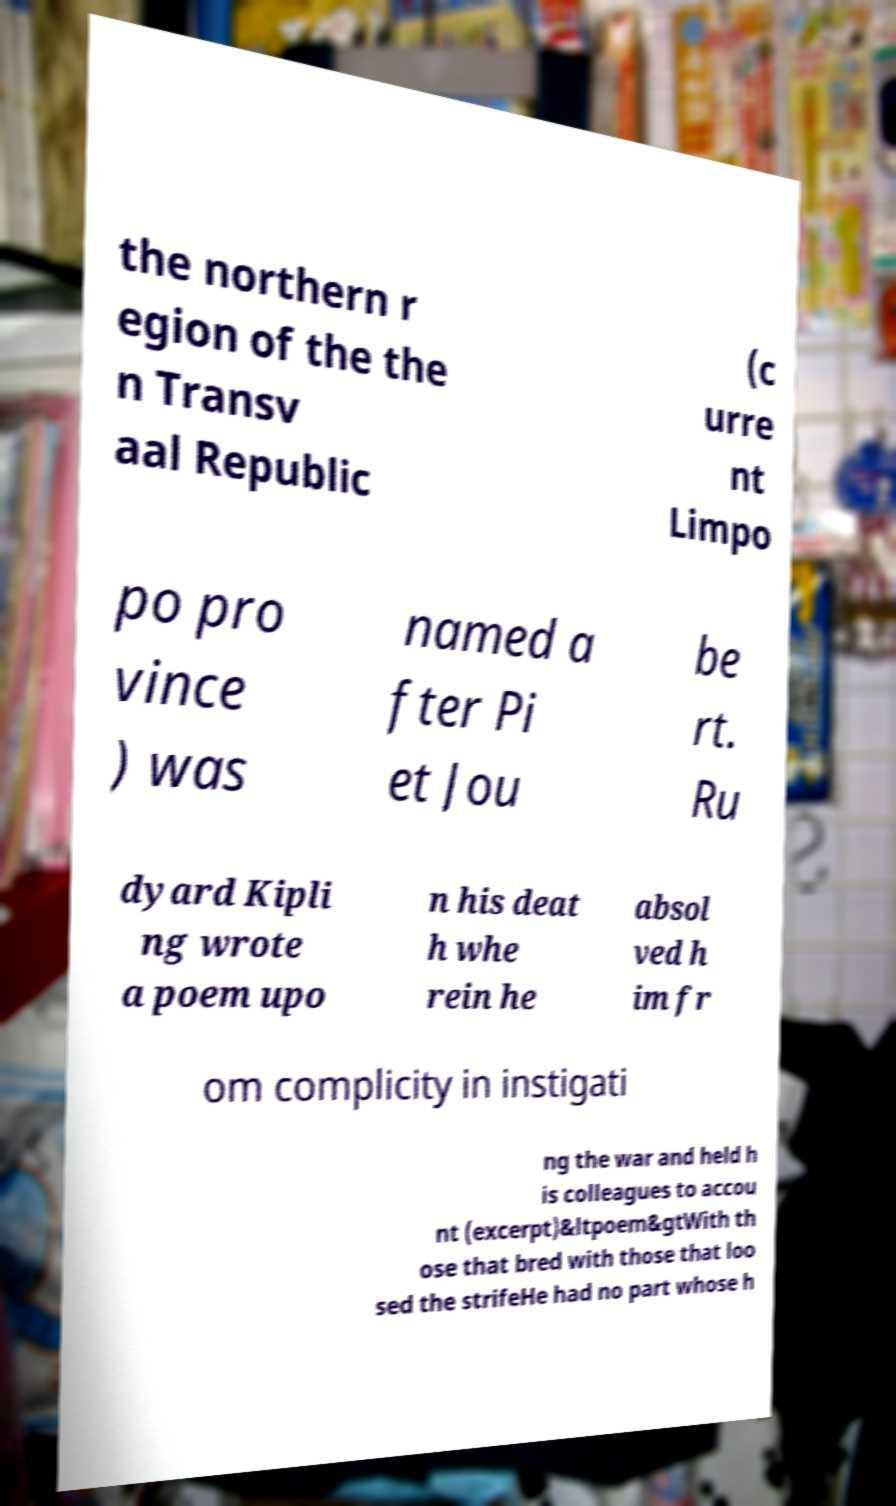Can you accurately transcribe the text from the provided image for me? the northern r egion of the the n Transv aal Republic (c urre nt Limpo po pro vince ) was named a fter Pi et Jou be rt. Ru dyard Kipli ng wrote a poem upo n his deat h whe rein he absol ved h im fr om complicity in instigati ng the war and held h is colleagues to accou nt (excerpt)&ltpoem&gtWith th ose that bred with those that loo sed the strifeHe had no part whose h 